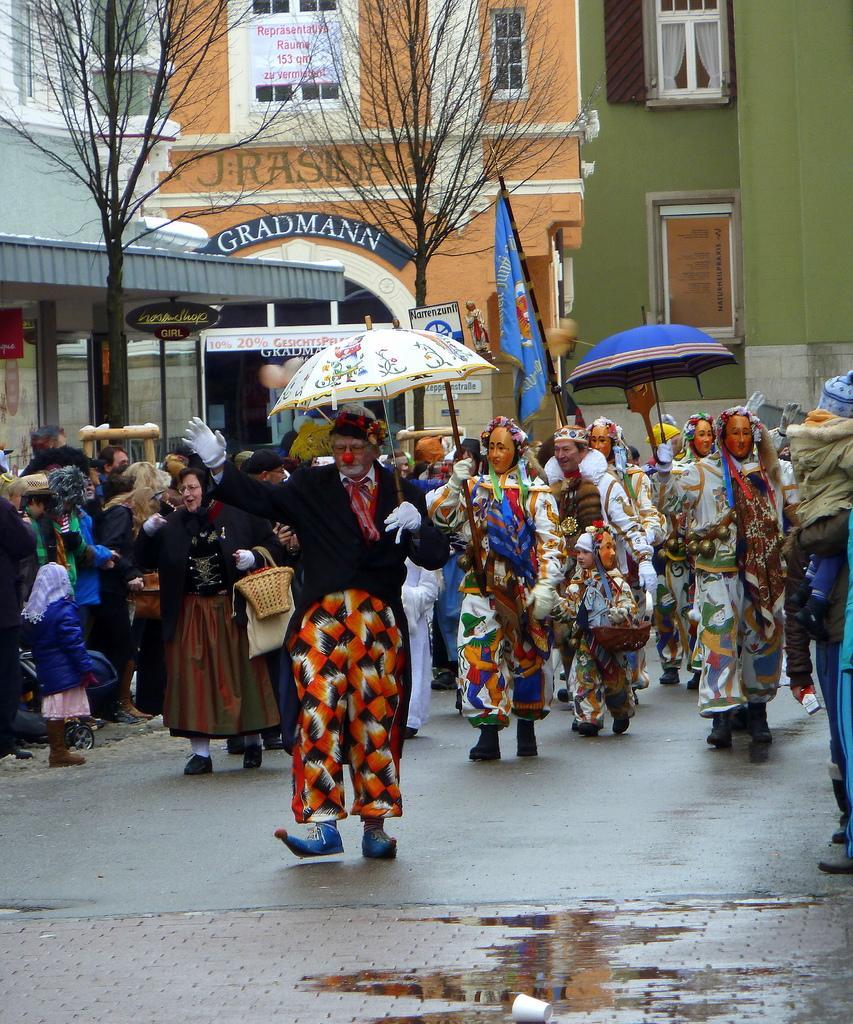How would you summarize this image in a sentence or two? In this picture we can see some people are in fancy dresses holding the umbrellas. On the left side of the people some people are standing and a person is holding a flag. Behind the people there are trees, buildings and boards. On the path there is a cup. 